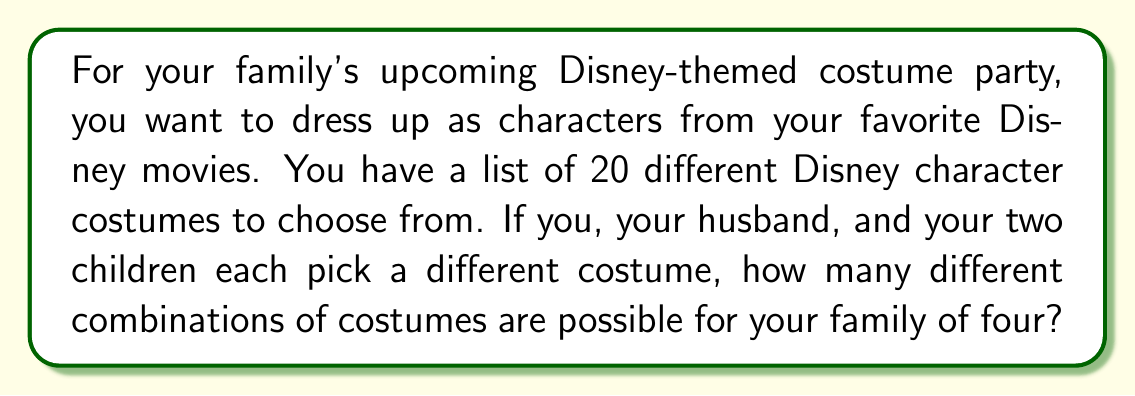Could you help me with this problem? Let's approach this step-by-step:

1) This is a permutation problem, as the order matters (who wears which costume).

2) We are selecting 4 costumes out of 20, without repetition (each family member wears a different costume).

3) The formula for permutations without repetition is:

   $$P(n,r) = \frac{n!}{(n-r)!}$$

   Where $n$ is the total number of items to choose from, and $r$ is the number of items being chosen.

4) In this case, $n = 20$ (total costumes) and $r = 4$ (family members).

5) Plugging these values into our formula:

   $$P(20,4) = \frac{20!}{(20-4)!} = \frac{20!}{16!}$$

6) Expanding this:
   
   $$\frac{20 * 19 * 18 * 17 * 16!}{16!}$$

7) The 16! cancels out in the numerator and denominator:

   $$20 * 19 * 18 * 17 = 116,280$$

Therefore, there are 116,280 different possible combinations of costumes for your family of four.
Answer: 116,280 combinations 